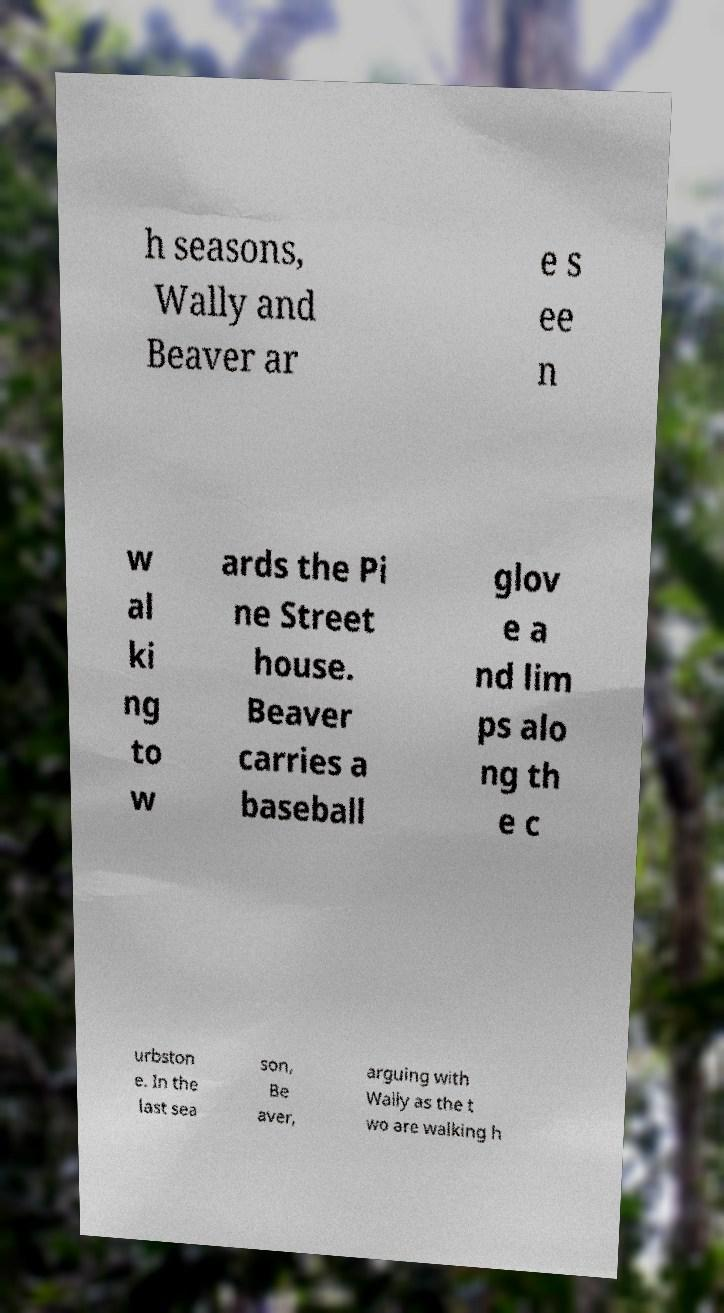Please identify and transcribe the text found in this image. h seasons, Wally and Beaver ar e s ee n w al ki ng to w ards the Pi ne Street house. Beaver carries a baseball glov e a nd lim ps alo ng th e c urbston e. In the last sea son, Be aver, arguing with Wally as the t wo are walking h 